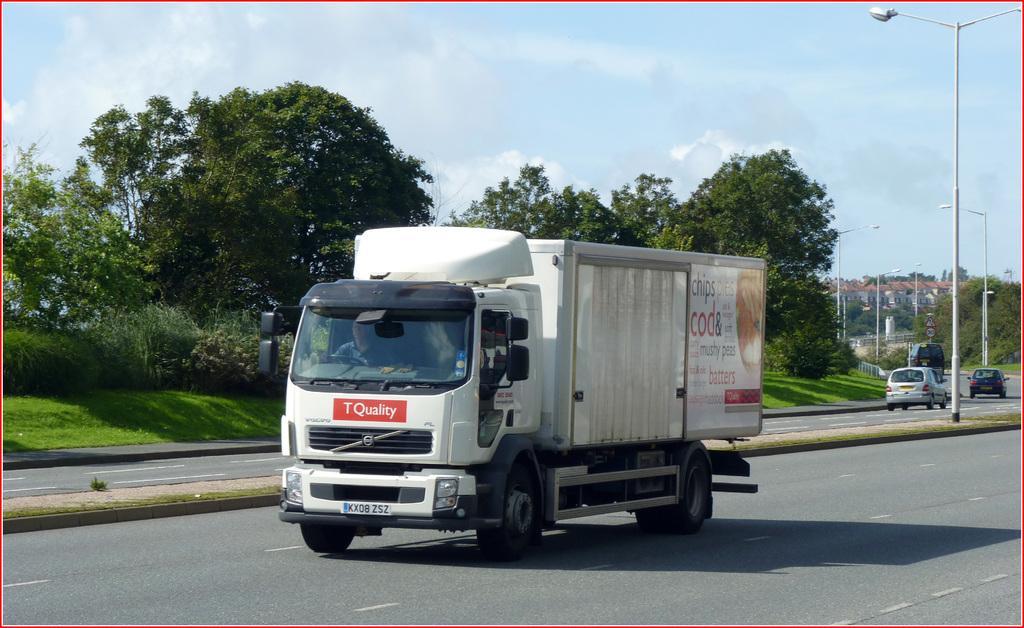Please provide a concise description of this image. In this image we can see many trees and plants. There are few vehicles in the image. There are many street lights in the image. There is a sky in the image. There is a grassy land in the image. There is a divider in the image. There are many houses in the image. 